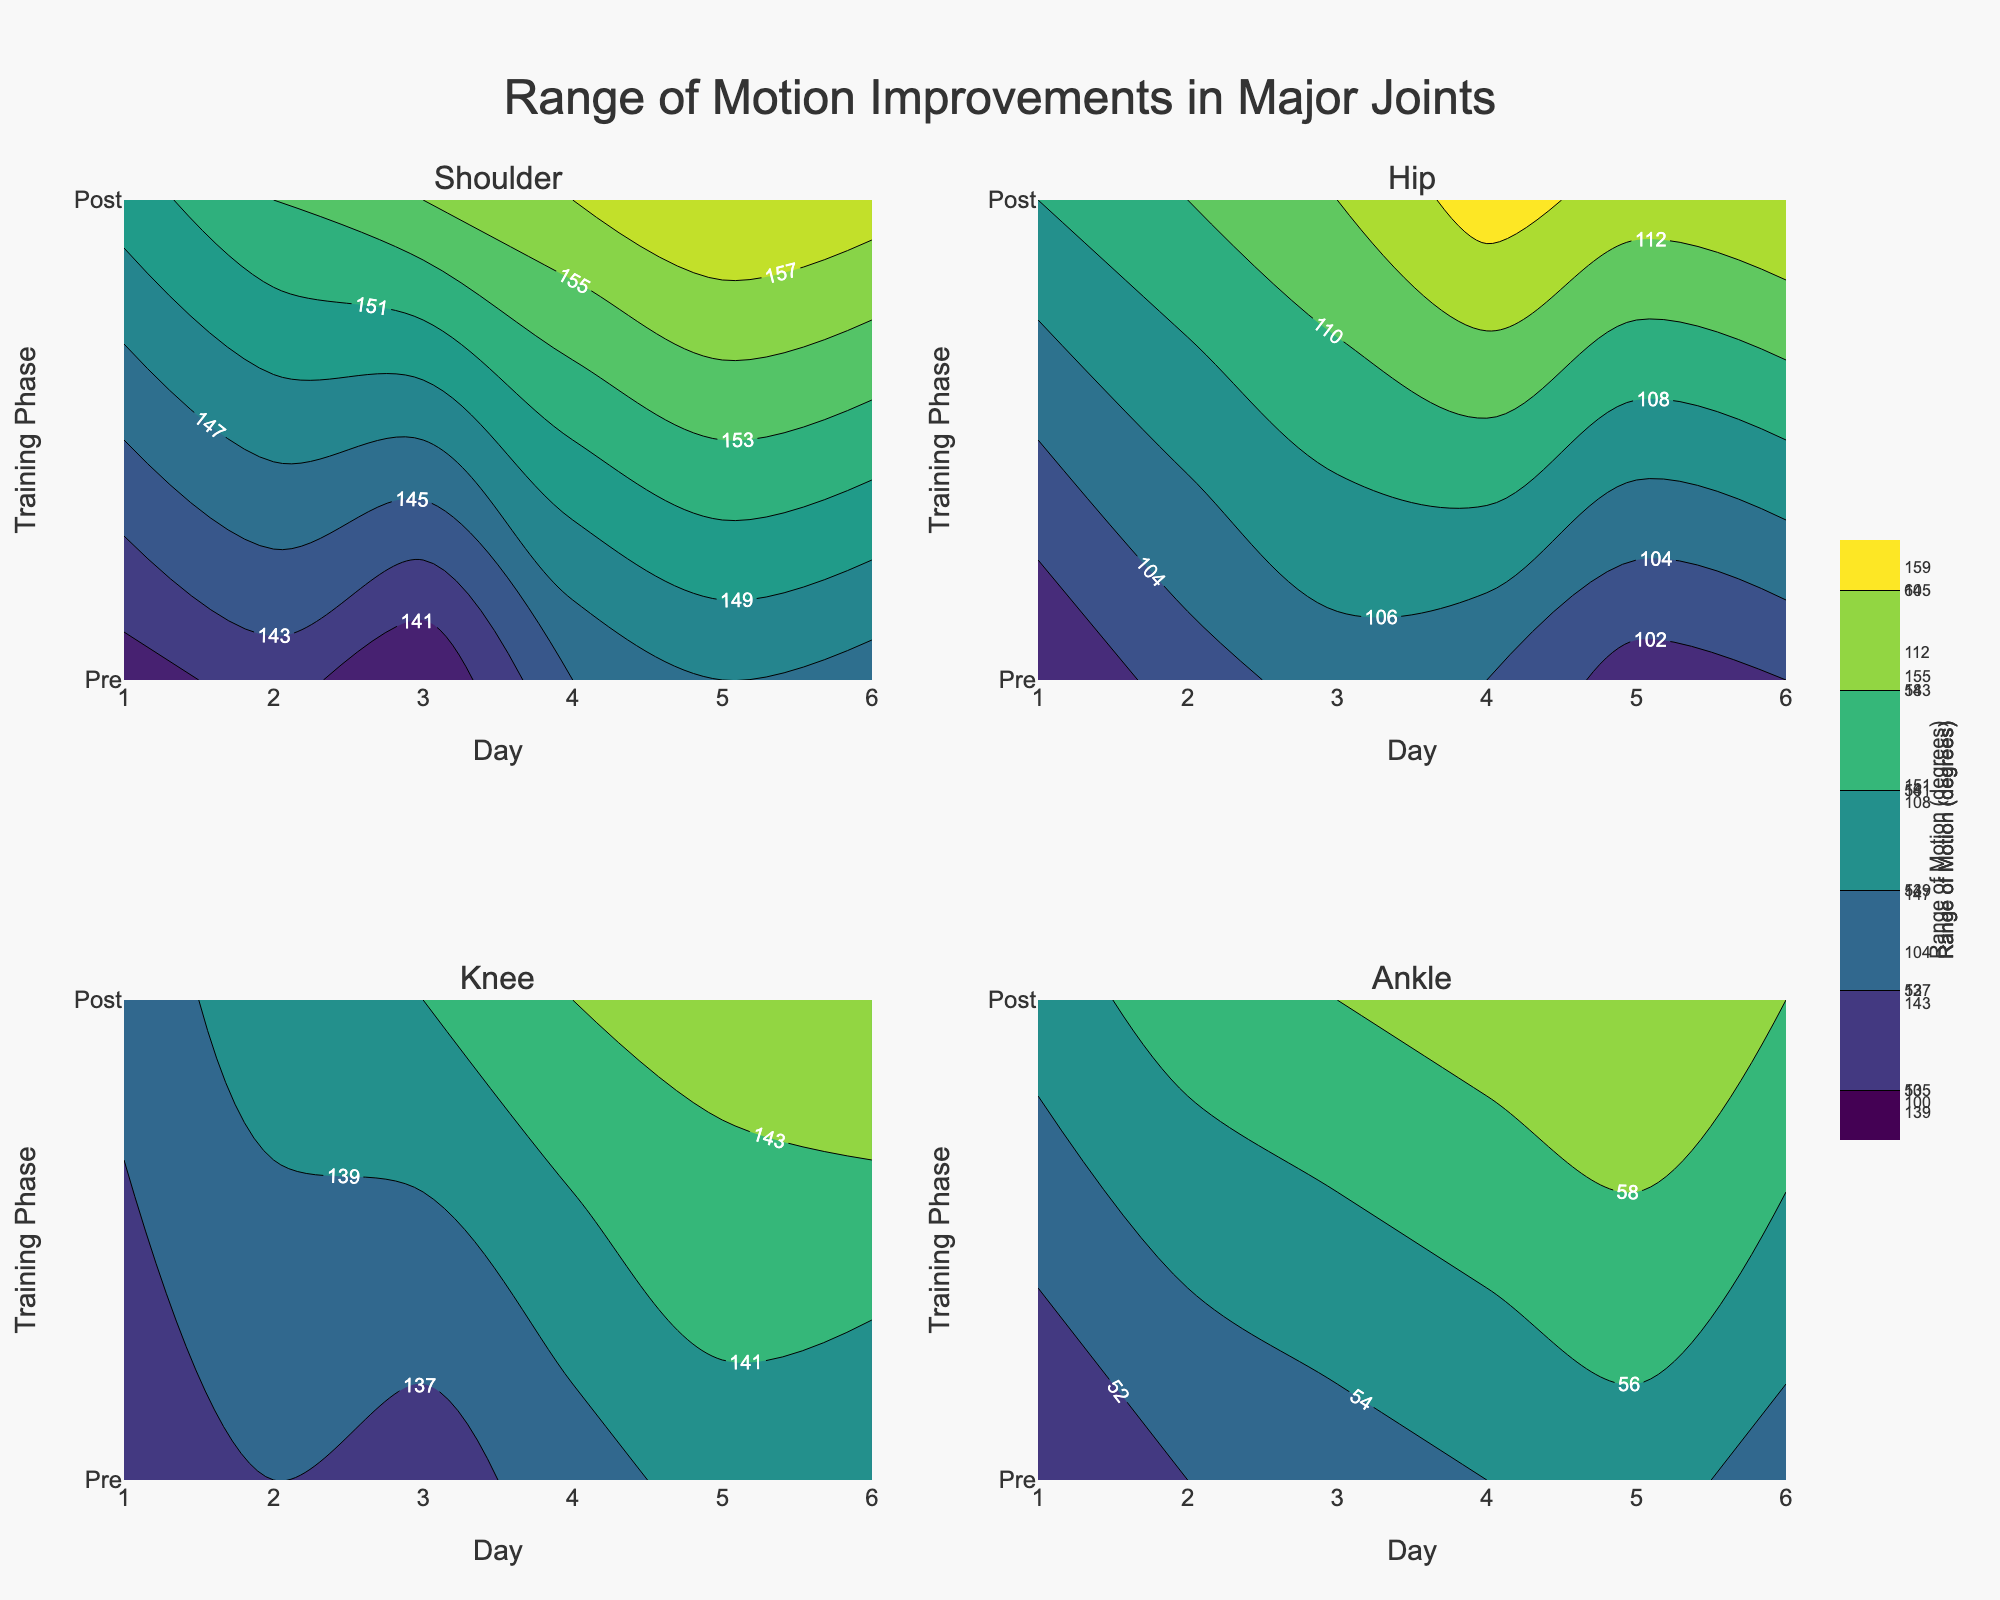What is the title of the figure? The title of the figure is usually displayed at the top in a larger or bold font. Here, it reads "Range of Motion Improvements in Major Joints".
Answer: Range of Motion Improvements in Major Joints What are the major joints evaluated in the figure? The subplot titles indicate the major joints evaluated. These are "Shoulder", "Hip", "Knee", and "Ankle".
Answer: Shoulder, Hip, Knee, Ankle Which joint shows the highest increase in range of motion post-training? By looking at the contour plots, you can compare the post-training values for each joint. The Shoulder joint shows the highest increase from 140-150 (Pre) to 150-159 (Post).
Answer: Shoulder How many days of data collection are displayed in each subplot? Each subplot shows data over a series of days numbered on the x-axis. The x-axis ranges from Day 1 to Day 6, so, there are 6 days of data collection.
Answer: 6 What color scale is used in the contour plots? The contour plots utilize the "Viridis" color scale, often shown in the legend or color bar that displays gradients from one color to another.
Answer: Viridis Between Pre and Post Training, which training phase shows a more prominent change in the Knee joint's range of motion? By examining the contour for the Knee joint, one can observe the difference between pre-training and post-training values. The range changes from 135-140 (Pre) to 138-145 (Post), indicating a more significant change post-training.
Answer: Post What is the range of motion improvement for the Hip joint from Day 1 to Day 6 post-training? To find this, look at the Post-Training contour line for the Hip joint from Day 1 to Day 6. The range of motion improves from 108 on Day 1 to 114 on Day 6.
Answer: 6 degrees What is the average range of motion improvement across all joints post-training? Calculate the range of motion improvements for each joint and average them. Shoulder: 150 to 157 (7 degrees), Hip: 108 to 114 (6 degrees), Knee: 138 to 142 (4 degrees), Ankle: 55 to 58 (3 degrees). Average is (7+6+4+3)/4 = 5 degrees.
Answer: 5 degrees Which joint had the least variation in range of motion post-training? By examining the contour plots, the Ankle's post-training variation is minimal compared to other joints, with the range being from 55 to 60.
Answer: Ankle 